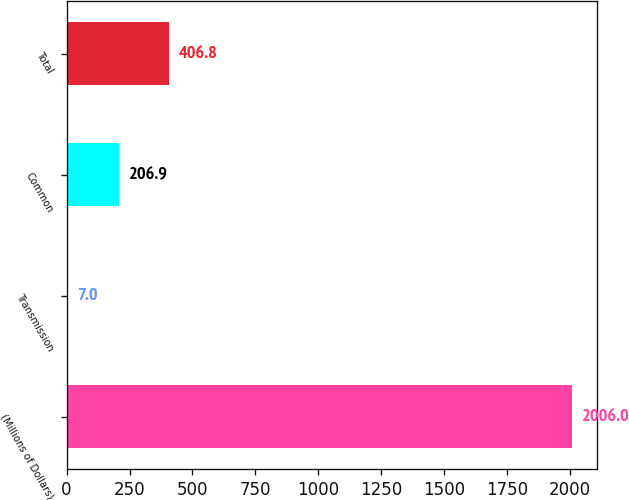<chart> <loc_0><loc_0><loc_500><loc_500><bar_chart><fcel>(Millions of Dollars)<fcel>Transmission<fcel>Common<fcel>Total<nl><fcel>2006<fcel>7<fcel>206.9<fcel>406.8<nl></chart> 